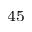<formula> <loc_0><loc_0><loc_500><loc_500>^ { 4 5 }</formula> 